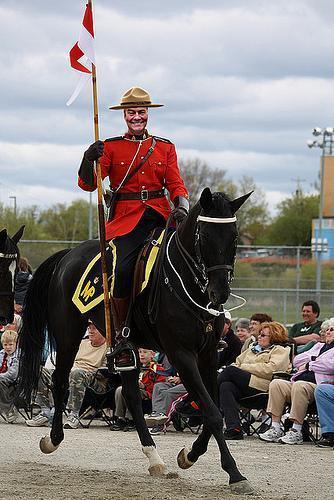How many horses are visible in this scene?
Give a very brief answer. 2. 